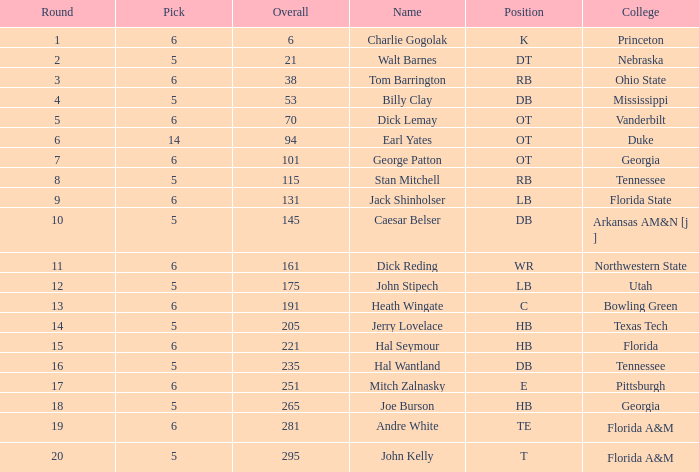What is the sum of Overall, when Pick is greater than 5, when Round is less than 11, and when Name is "Tom Barrington"? 38.0. 